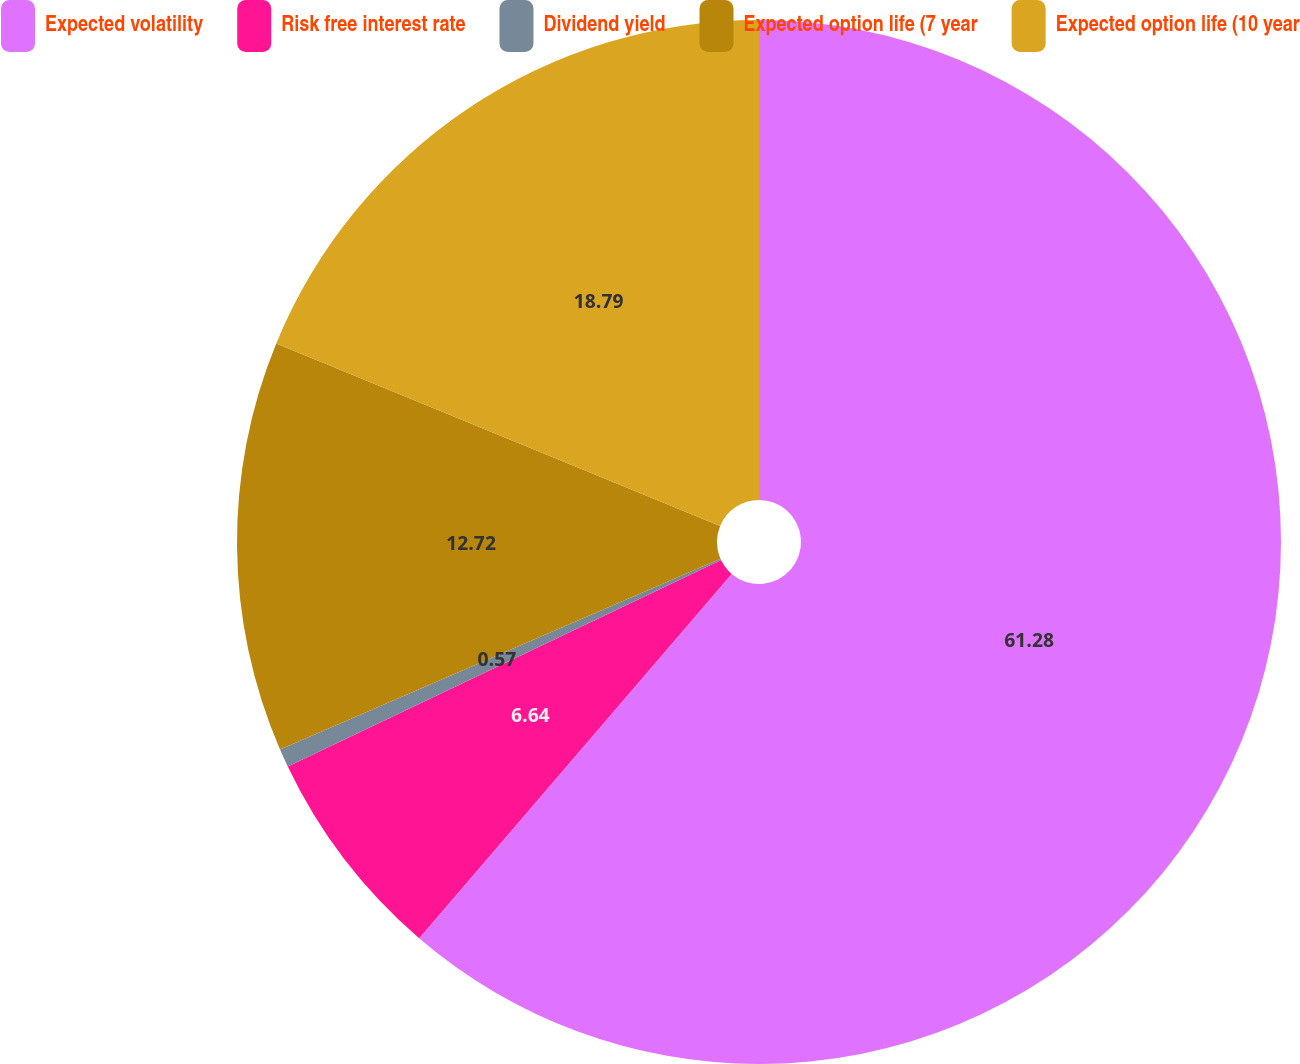Convert chart. <chart><loc_0><loc_0><loc_500><loc_500><pie_chart><fcel>Expected volatility<fcel>Risk free interest rate<fcel>Dividend yield<fcel>Expected option life (7 year<fcel>Expected option life (10 year<nl><fcel>61.29%<fcel>6.64%<fcel>0.57%<fcel>12.72%<fcel>18.79%<nl></chart> 